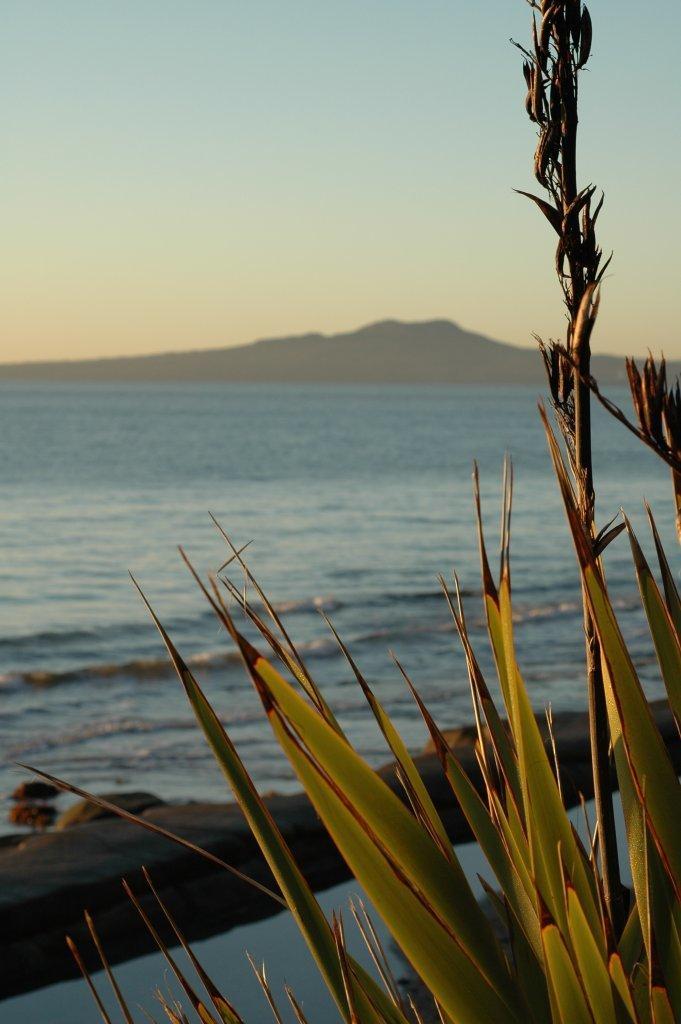Can you describe this image briefly? In this image there are tall leaves with thorns to it. In the background there is water. At the top there is the sky. On the left side bottom there are stones. In the background there are mountains. 